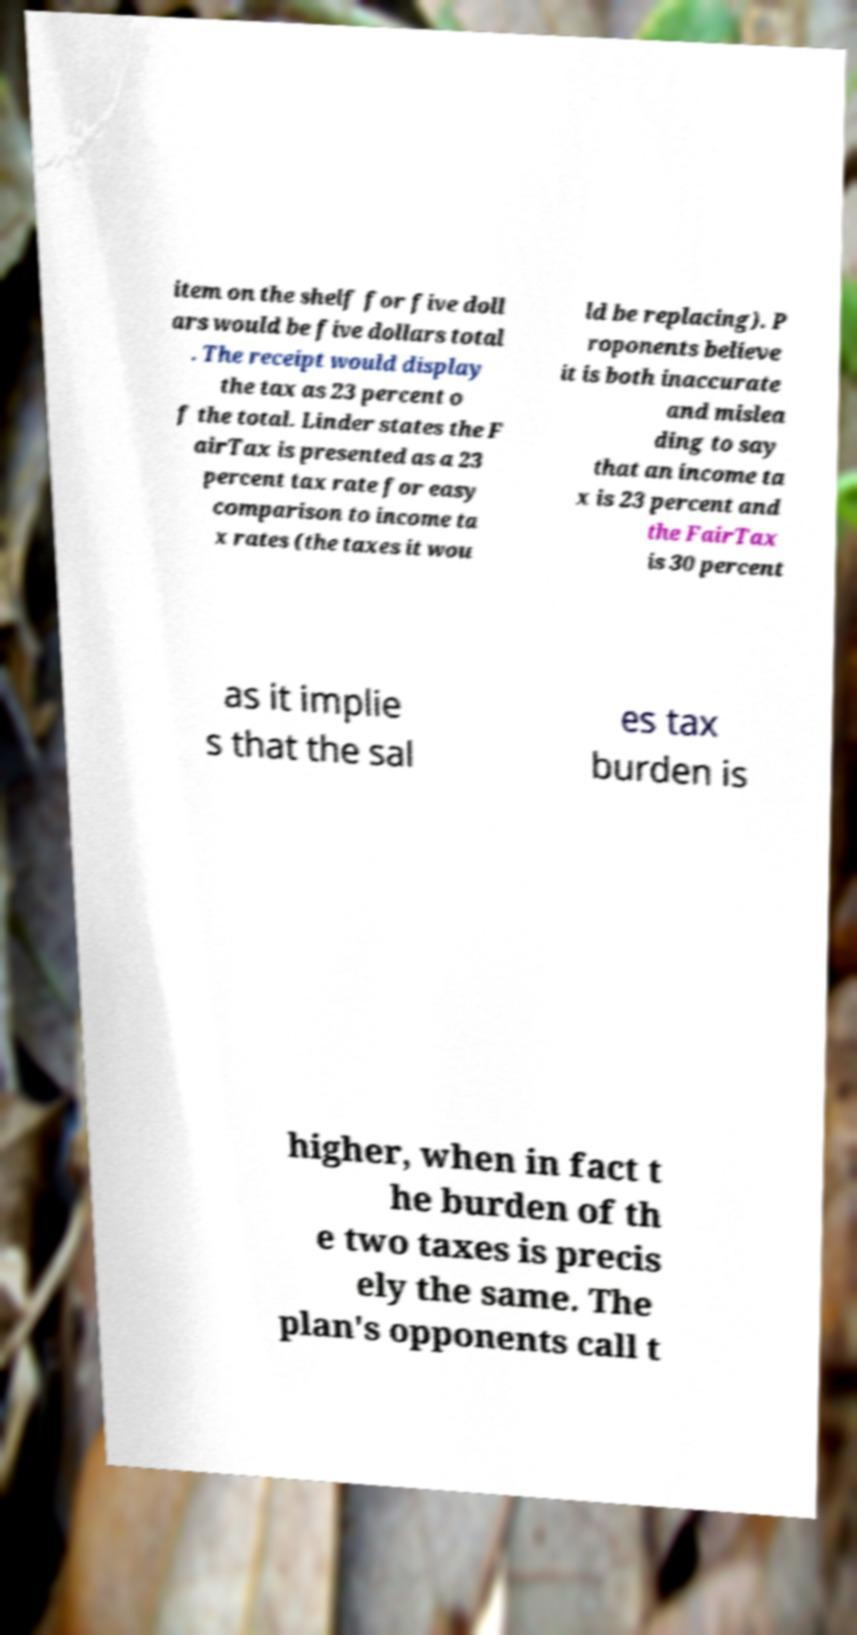I need the written content from this picture converted into text. Can you do that? item on the shelf for five doll ars would be five dollars total . The receipt would display the tax as 23 percent o f the total. Linder states the F airTax is presented as a 23 percent tax rate for easy comparison to income ta x rates (the taxes it wou ld be replacing). P roponents believe it is both inaccurate and mislea ding to say that an income ta x is 23 percent and the FairTax is 30 percent as it implie s that the sal es tax burden is higher, when in fact t he burden of th e two taxes is precis ely the same. The plan's opponents call t 